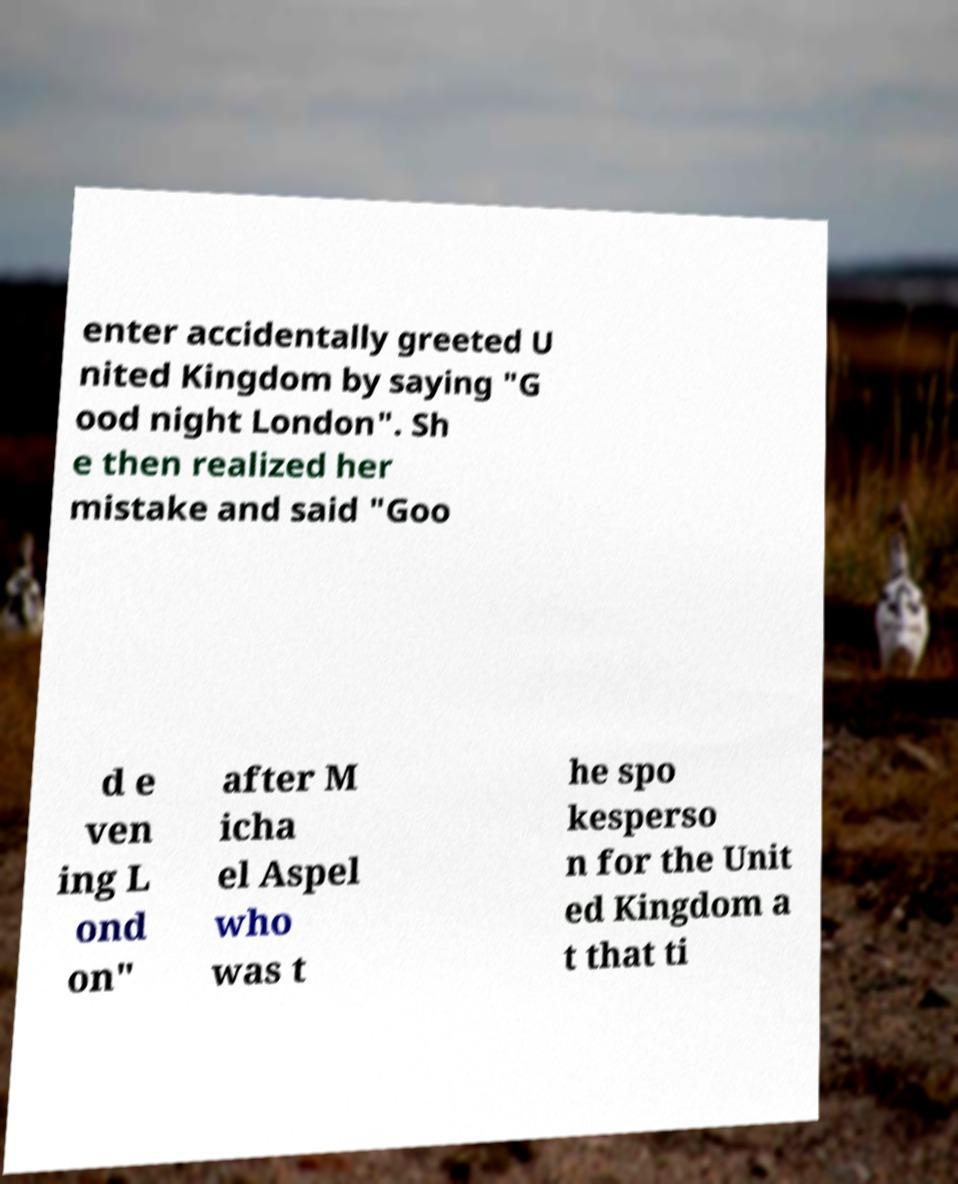Can you read and provide the text displayed in the image?This photo seems to have some interesting text. Can you extract and type it out for me? enter accidentally greeted U nited Kingdom by saying "G ood night London". Sh e then realized her mistake and said "Goo d e ven ing L ond on" after M icha el Aspel who was t he spo kesperso n for the Unit ed Kingdom a t that ti 